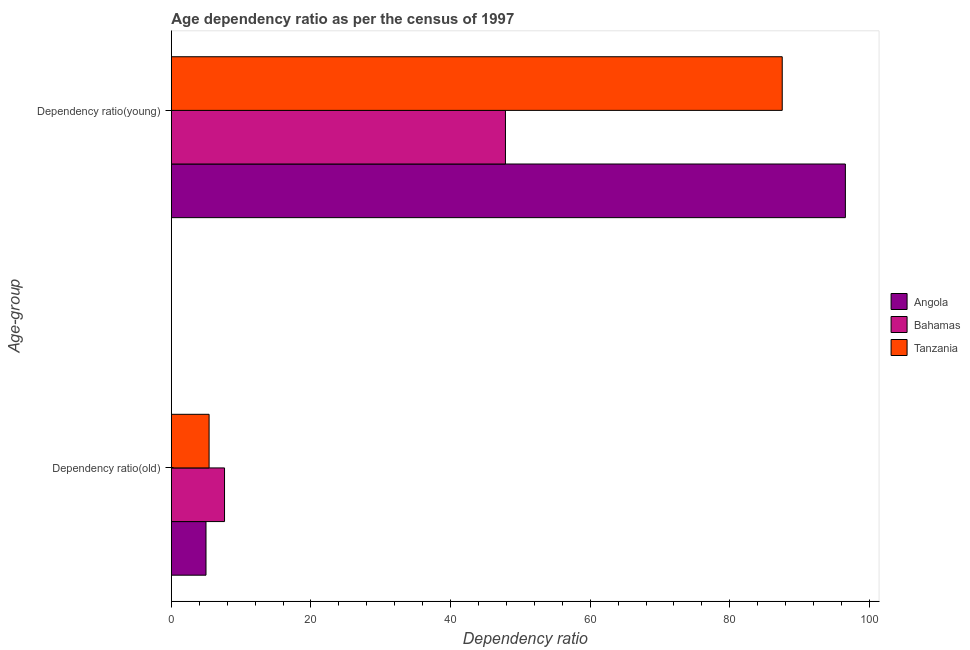How many different coloured bars are there?
Provide a short and direct response. 3. Are the number of bars per tick equal to the number of legend labels?
Your answer should be very brief. Yes. How many bars are there on the 1st tick from the top?
Your answer should be compact. 3. How many bars are there on the 2nd tick from the bottom?
Give a very brief answer. 3. What is the label of the 1st group of bars from the top?
Provide a succinct answer. Dependency ratio(young). What is the age dependency ratio(young) in Angola?
Your answer should be compact. 96.56. Across all countries, what is the maximum age dependency ratio(young)?
Your answer should be compact. 96.56. Across all countries, what is the minimum age dependency ratio(young)?
Your response must be concise. 47.86. In which country was the age dependency ratio(old) maximum?
Your answer should be very brief. Bahamas. In which country was the age dependency ratio(young) minimum?
Your response must be concise. Bahamas. What is the total age dependency ratio(old) in the graph?
Your answer should be very brief. 17.98. What is the difference between the age dependency ratio(old) in Tanzania and that in Angola?
Give a very brief answer. 0.44. What is the difference between the age dependency ratio(young) in Tanzania and the age dependency ratio(old) in Angola?
Offer a terse response. 82.55. What is the average age dependency ratio(young) per country?
Give a very brief answer. 77.31. What is the difference between the age dependency ratio(young) and age dependency ratio(old) in Tanzania?
Ensure brevity in your answer.  82.11. What is the ratio of the age dependency ratio(old) in Tanzania to that in Bahamas?
Keep it short and to the point. 0.71. In how many countries, is the age dependency ratio(young) greater than the average age dependency ratio(young) taken over all countries?
Provide a succinct answer. 2. What does the 2nd bar from the top in Dependency ratio(young) represents?
Offer a terse response. Bahamas. What does the 1st bar from the bottom in Dependency ratio(old) represents?
Keep it short and to the point. Angola. Are all the bars in the graph horizontal?
Provide a short and direct response. Yes. Are the values on the major ticks of X-axis written in scientific E-notation?
Provide a succinct answer. No. Does the graph contain any zero values?
Make the answer very short. No. Where does the legend appear in the graph?
Your answer should be compact. Center right. How many legend labels are there?
Provide a short and direct response. 3. What is the title of the graph?
Give a very brief answer. Age dependency ratio as per the census of 1997. What is the label or title of the X-axis?
Offer a terse response. Dependency ratio. What is the label or title of the Y-axis?
Provide a short and direct response. Age-group. What is the Dependency ratio in Angola in Dependency ratio(old)?
Your answer should be compact. 4.96. What is the Dependency ratio of Bahamas in Dependency ratio(old)?
Provide a short and direct response. 7.61. What is the Dependency ratio in Tanzania in Dependency ratio(old)?
Make the answer very short. 5.4. What is the Dependency ratio in Angola in Dependency ratio(young)?
Your response must be concise. 96.56. What is the Dependency ratio in Bahamas in Dependency ratio(young)?
Your answer should be compact. 47.86. What is the Dependency ratio of Tanzania in Dependency ratio(young)?
Your response must be concise. 87.51. Across all Age-group, what is the maximum Dependency ratio in Angola?
Give a very brief answer. 96.56. Across all Age-group, what is the maximum Dependency ratio of Bahamas?
Offer a very short reply. 47.86. Across all Age-group, what is the maximum Dependency ratio in Tanzania?
Provide a short and direct response. 87.51. Across all Age-group, what is the minimum Dependency ratio of Angola?
Provide a succinct answer. 4.96. Across all Age-group, what is the minimum Dependency ratio in Bahamas?
Your answer should be very brief. 7.61. Across all Age-group, what is the minimum Dependency ratio in Tanzania?
Give a very brief answer. 5.4. What is the total Dependency ratio in Angola in the graph?
Keep it short and to the point. 101.52. What is the total Dependency ratio in Bahamas in the graph?
Offer a very short reply. 55.47. What is the total Dependency ratio in Tanzania in the graph?
Your answer should be very brief. 92.92. What is the difference between the Dependency ratio of Angola in Dependency ratio(old) and that in Dependency ratio(young)?
Provide a succinct answer. -91.6. What is the difference between the Dependency ratio of Bahamas in Dependency ratio(old) and that in Dependency ratio(young)?
Ensure brevity in your answer.  -40.25. What is the difference between the Dependency ratio of Tanzania in Dependency ratio(old) and that in Dependency ratio(young)?
Provide a succinct answer. -82.11. What is the difference between the Dependency ratio of Angola in Dependency ratio(old) and the Dependency ratio of Bahamas in Dependency ratio(young)?
Ensure brevity in your answer.  -42.9. What is the difference between the Dependency ratio of Angola in Dependency ratio(old) and the Dependency ratio of Tanzania in Dependency ratio(young)?
Your answer should be very brief. -82.55. What is the difference between the Dependency ratio in Bahamas in Dependency ratio(old) and the Dependency ratio in Tanzania in Dependency ratio(young)?
Provide a short and direct response. -79.9. What is the average Dependency ratio in Angola per Age-group?
Give a very brief answer. 50.76. What is the average Dependency ratio of Bahamas per Age-group?
Offer a terse response. 27.74. What is the average Dependency ratio in Tanzania per Age-group?
Provide a short and direct response. 46.46. What is the difference between the Dependency ratio in Angola and Dependency ratio in Bahamas in Dependency ratio(old)?
Provide a short and direct response. -2.65. What is the difference between the Dependency ratio in Angola and Dependency ratio in Tanzania in Dependency ratio(old)?
Provide a short and direct response. -0.44. What is the difference between the Dependency ratio of Bahamas and Dependency ratio of Tanzania in Dependency ratio(old)?
Your response must be concise. 2.21. What is the difference between the Dependency ratio in Angola and Dependency ratio in Bahamas in Dependency ratio(young)?
Your response must be concise. 48.7. What is the difference between the Dependency ratio of Angola and Dependency ratio of Tanzania in Dependency ratio(young)?
Provide a short and direct response. 9.05. What is the difference between the Dependency ratio of Bahamas and Dependency ratio of Tanzania in Dependency ratio(young)?
Your answer should be very brief. -39.65. What is the ratio of the Dependency ratio of Angola in Dependency ratio(old) to that in Dependency ratio(young)?
Offer a very short reply. 0.05. What is the ratio of the Dependency ratio of Bahamas in Dependency ratio(old) to that in Dependency ratio(young)?
Make the answer very short. 0.16. What is the ratio of the Dependency ratio in Tanzania in Dependency ratio(old) to that in Dependency ratio(young)?
Keep it short and to the point. 0.06. What is the difference between the highest and the second highest Dependency ratio of Angola?
Your answer should be compact. 91.6. What is the difference between the highest and the second highest Dependency ratio of Bahamas?
Make the answer very short. 40.25. What is the difference between the highest and the second highest Dependency ratio in Tanzania?
Keep it short and to the point. 82.11. What is the difference between the highest and the lowest Dependency ratio in Angola?
Make the answer very short. 91.6. What is the difference between the highest and the lowest Dependency ratio in Bahamas?
Keep it short and to the point. 40.25. What is the difference between the highest and the lowest Dependency ratio of Tanzania?
Provide a succinct answer. 82.11. 